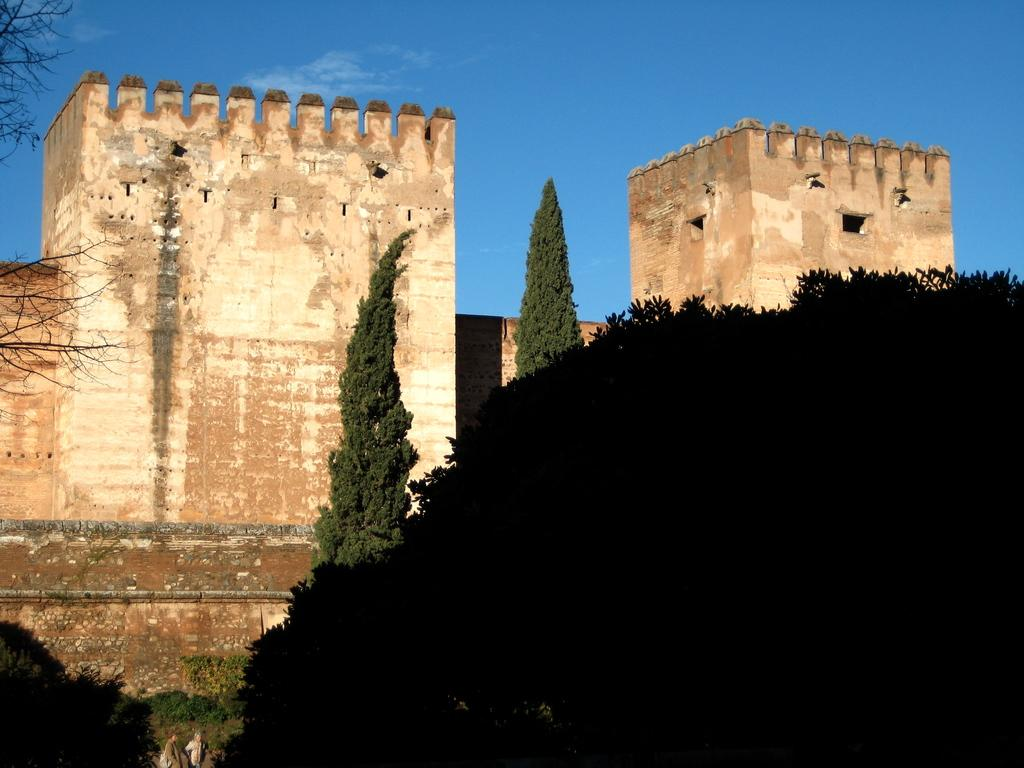What type of view is shown in the image? The image is an outside view. What can be seen at the bottom of the image? There are many trees at the bottom of the image. What is located in the middle of the image? There are few buildings in the middle of the image. What is visible at the top of the image? The sky is visible at the top of the image. What color is the sky in the image? The color of the sky is blue. Where is the coast visible in the image? There is no coast visible in the image; it features an outside view with trees, buildings, and a blue sky. What type of map is shown in the image? There is no map present in the image. 